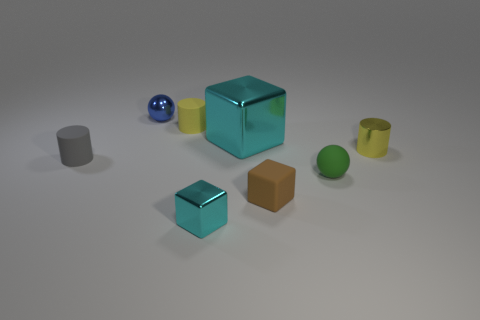Add 1 small brown cylinders. How many objects exist? 9 Subtract all cylinders. How many objects are left? 5 Add 5 blocks. How many blocks are left? 8 Add 8 tiny yellow metallic objects. How many tiny yellow metallic objects exist? 9 Subtract 0 brown cylinders. How many objects are left? 8 Subtract all tiny gray matte cylinders. Subtract all large cyan cubes. How many objects are left? 6 